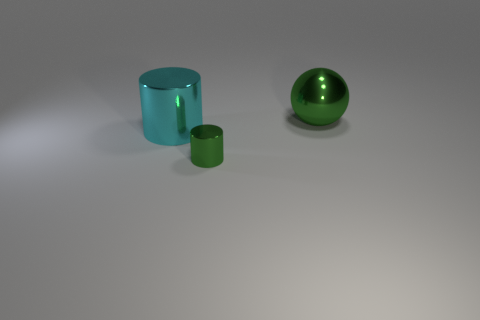How many cyan metallic objects are the same shape as the big green shiny thing?
Make the answer very short. 0. How many cylinders are either green objects or blue metallic things?
Provide a succinct answer. 1. There is a green object that is to the right of the small green thing; is it the same shape as the big shiny thing in front of the sphere?
Provide a short and direct response. No. What material is the cyan thing?
Make the answer very short. Metal. What is the shape of the small object that is the same color as the big shiny ball?
Make the answer very short. Cylinder. How many other cyan metallic objects have the same size as the cyan object?
Offer a terse response. 0. What number of objects are big shiny objects behind the cyan metal object or large objects that are right of the small cylinder?
Your response must be concise. 1. Are the green thing in front of the large metal cylinder and the large thing that is in front of the big green metallic ball made of the same material?
Provide a succinct answer. Yes. There is a green object that is in front of the large metallic object that is in front of the big green shiny sphere; what is its shape?
Offer a terse response. Cylinder. Is there anything else that has the same color as the large sphere?
Offer a very short reply. Yes. 